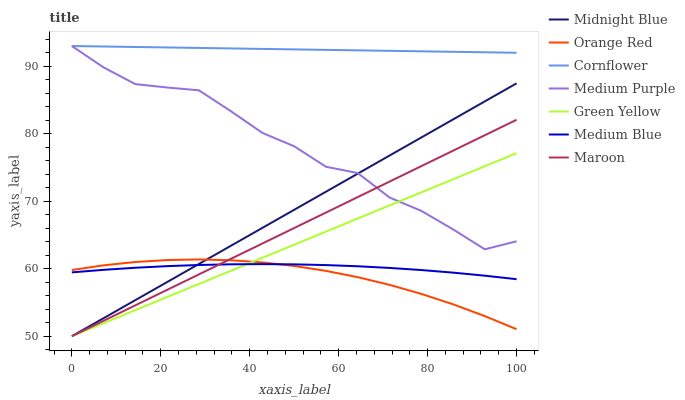Does Orange Red have the minimum area under the curve?
Answer yes or no. Yes. Does Cornflower have the maximum area under the curve?
Answer yes or no. Yes. Does Midnight Blue have the minimum area under the curve?
Answer yes or no. No. Does Midnight Blue have the maximum area under the curve?
Answer yes or no. No. Is Cornflower the smoothest?
Answer yes or no. Yes. Is Medium Purple the roughest?
Answer yes or no. Yes. Is Midnight Blue the smoothest?
Answer yes or no. No. Is Midnight Blue the roughest?
Answer yes or no. No. Does Medium Blue have the lowest value?
Answer yes or no. No. Does Medium Purple have the highest value?
Answer yes or no. Yes. Does Midnight Blue have the highest value?
Answer yes or no. No. Is Medium Blue less than Cornflower?
Answer yes or no. Yes. Is Medium Purple greater than Medium Blue?
Answer yes or no. Yes. Does Orange Red intersect Green Yellow?
Answer yes or no. Yes. Is Orange Red less than Green Yellow?
Answer yes or no. No. Is Orange Red greater than Green Yellow?
Answer yes or no. No. Does Medium Blue intersect Cornflower?
Answer yes or no. No. 